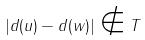Convert formula to latex. <formula><loc_0><loc_0><loc_500><loc_500>| d ( u ) - d ( w ) | \notin T</formula> 